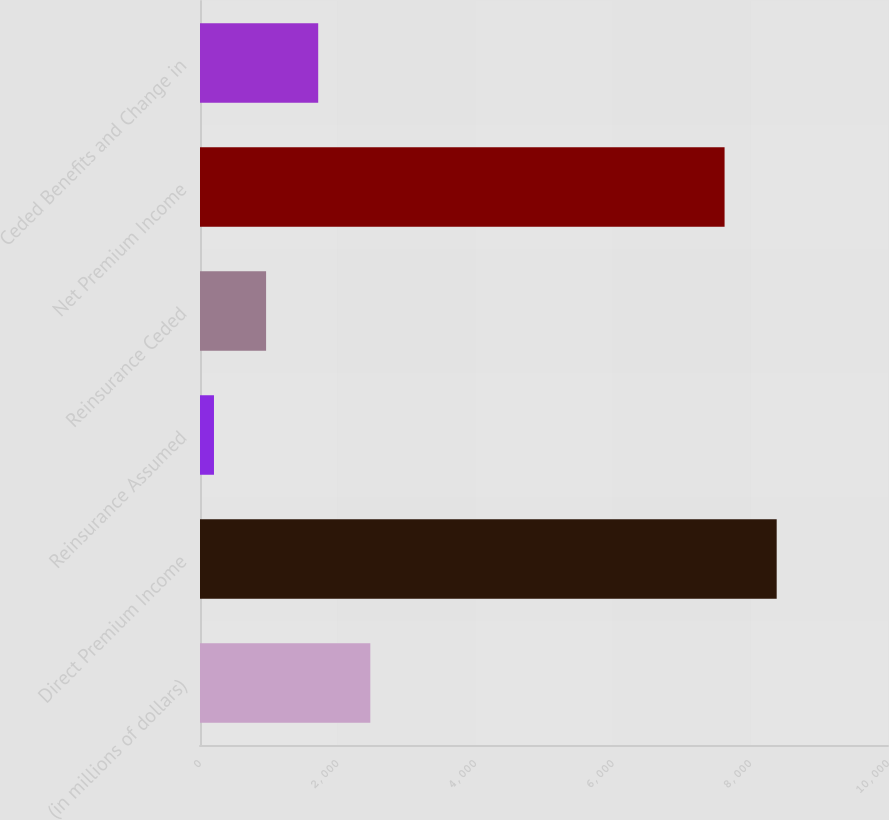<chart> <loc_0><loc_0><loc_500><loc_500><bar_chart><fcel>(in millions of dollars)<fcel>Direct Premium Income<fcel>Reinsurance Assumed<fcel>Reinsurance Ceded<fcel>Net Premium Income<fcel>Ceded Benefits and Change in<nl><fcel>2475.43<fcel>8382.11<fcel>203.2<fcel>960.61<fcel>7624.7<fcel>1718.02<nl></chart> 